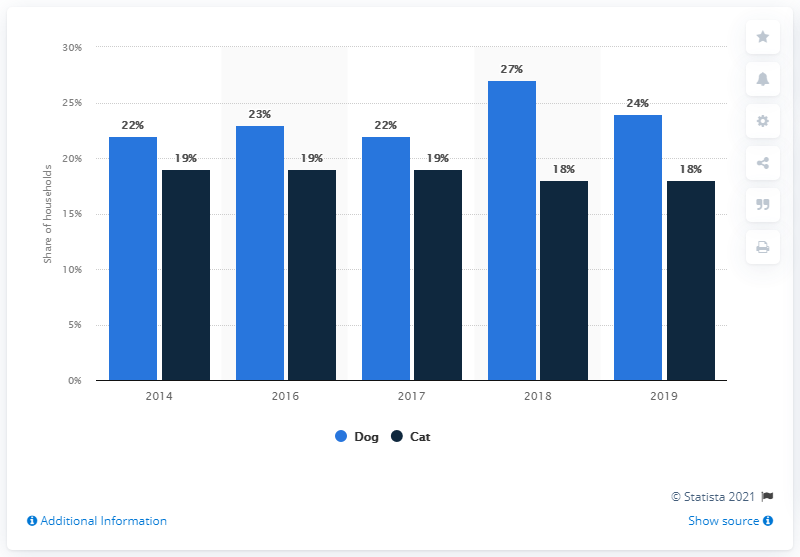Indicate a few pertinent items in this graphic. In 2019, approximately 18% of Italian households owned at least one cat, according to recent statistics. 